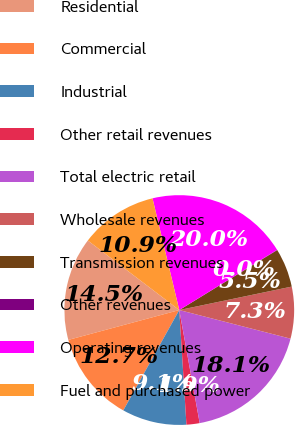Convert chart. <chart><loc_0><loc_0><loc_500><loc_500><pie_chart><fcel>Residential<fcel>Commercial<fcel>Industrial<fcel>Other retail revenues<fcel>Total electric retail<fcel>Wholesale revenues<fcel>Transmission revenues<fcel>Other revenues<fcel>Operating revenues<fcel>Fuel and purchased power<nl><fcel>14.53%<fcel>12.72%<fcel>9.09%<fcel>1.85%<fcel>18.15%<fcel>7.28%<fcel>5.47%<fcel>0.04%<fcel>19.96%<fcel>10.91%<nl></chart> 